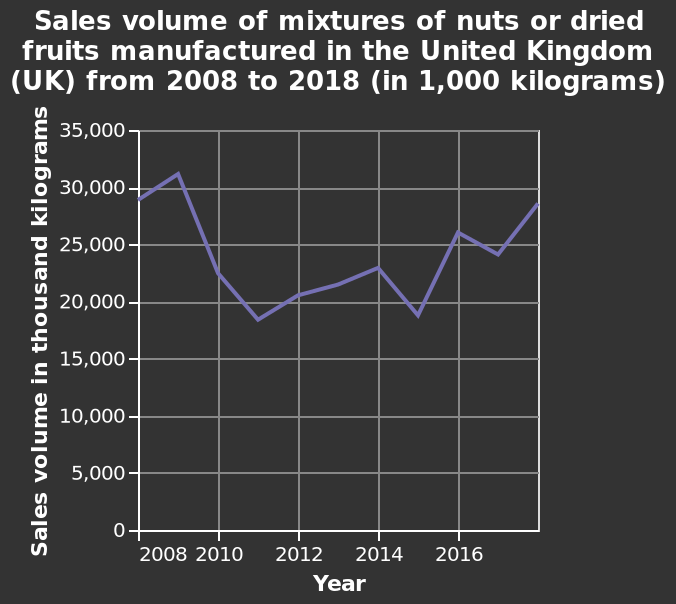<image>
What does the x-axis represent on the line graph?  The x-axis on the line graph represents the years from 2008 to 2016. 